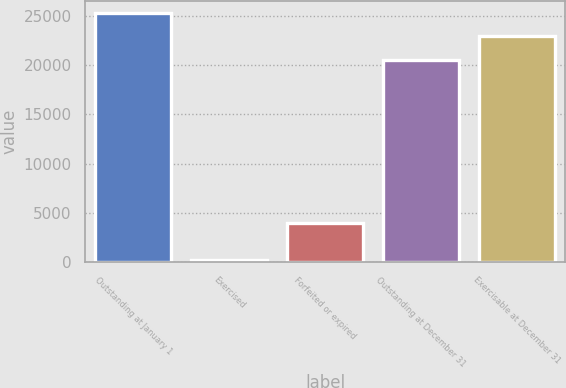Convert chart. <chart><loc_0><loc_0><loc_500><loc_500><bar_chart><fcel>Outstanding at January 1<fcel>Exercised<fcel>Forfeited or expired<fcel>Outstanding at December 31<fcel>Exercisable at December 31<nl><fcel>25252.6<fcel>202<fcel>4012<fcel>20564<fcel>22908.3<nl></chart> 